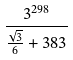Convert formula to latex. <formula><loc_0><loc_0><loc_500><loc_500>\frac { 3 ^ { 2 9 8 } } { \frac { \sqrt { 3 } } { 6 } + 3 8 3 }</formula> 